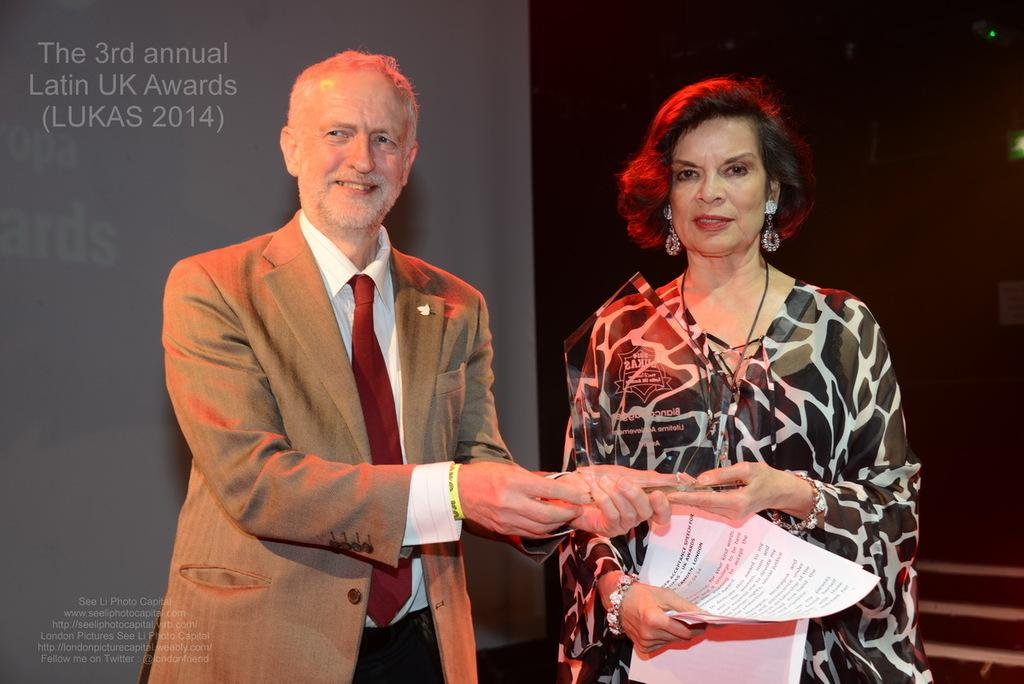What is the man in the image wearing? The man is wearing a brown suit. What is the man doing in the image? The man is giving an award to a woman. What is the woman wearing in the image? The woman is wearing a black top. What can be seen in the background of the image? There is a grey banner in the background, and the background is dark. What type of education can be seen growing in the image? There is no education or crops present in the image; it features a man giving an award to a woman. What is the rate of corn production in the image? There is no corn or production rate mentioned in the image. 